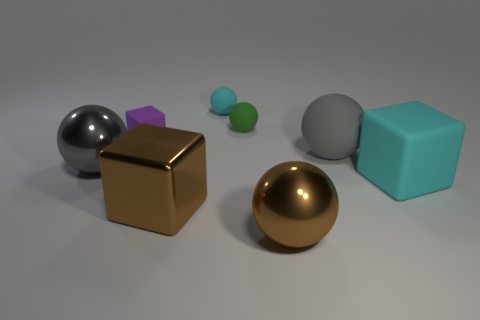Add 2 green matte things. How many objects exist? 10 Subtract all cubes. How many objects are left? 5 Add 6 gray metal spheres. How many gray metal spheres are left? 7 Add 3 large gray spheres. How many large gray spheres exist? 5 Subtract 1 purple blocks. How many objects are left? 7 Subtract all large rubber things. Subtract all purple rubber things. How many objects are left? 5 